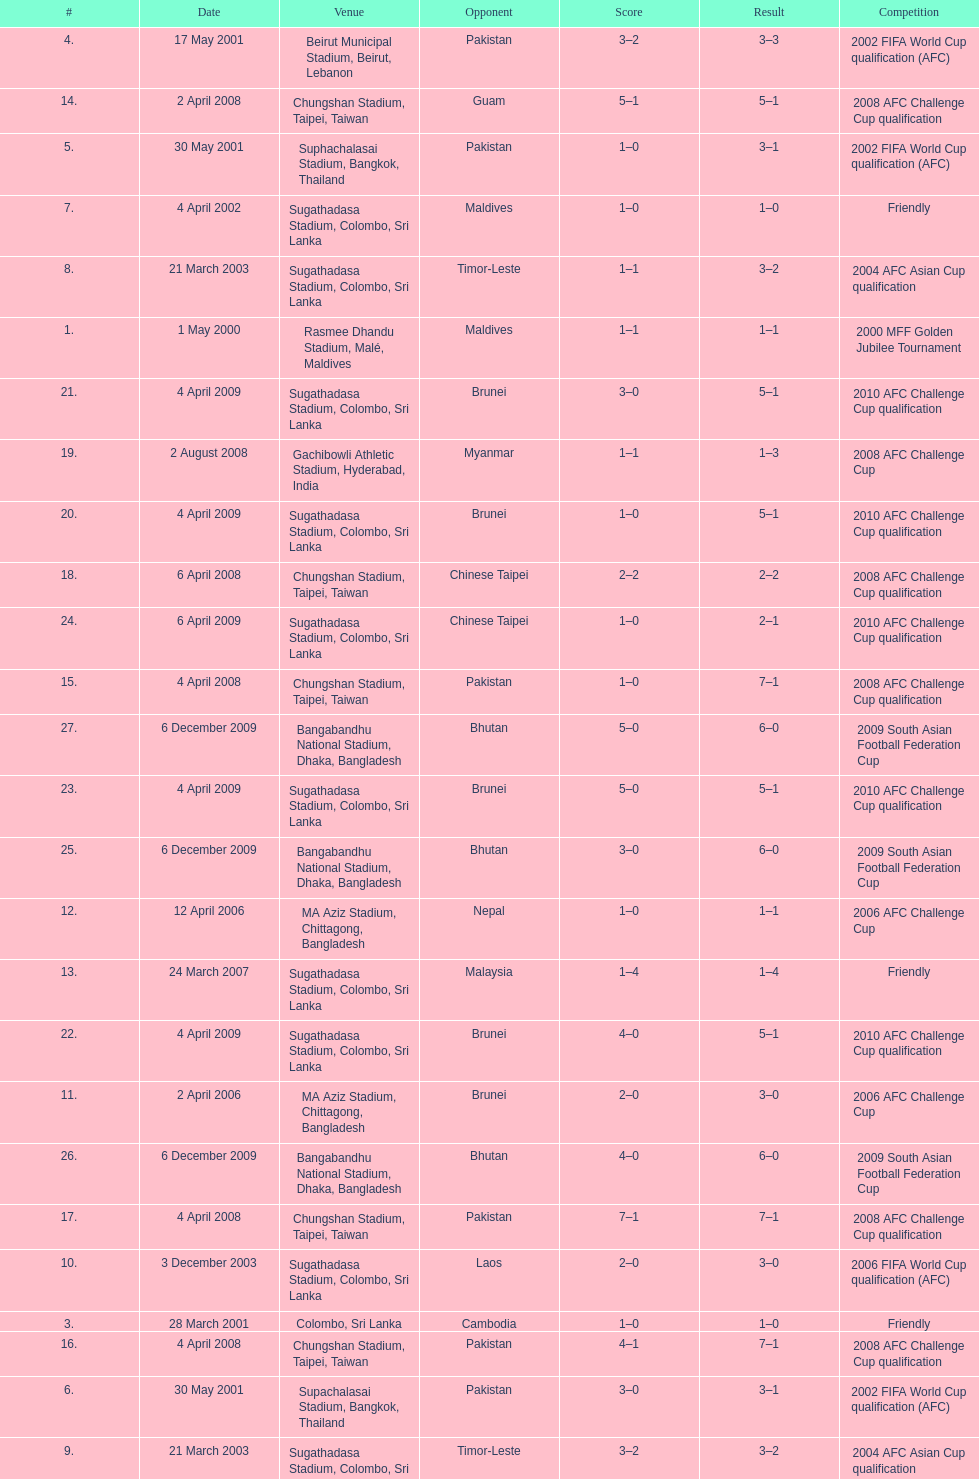How many times was laos the opponent? 1. 